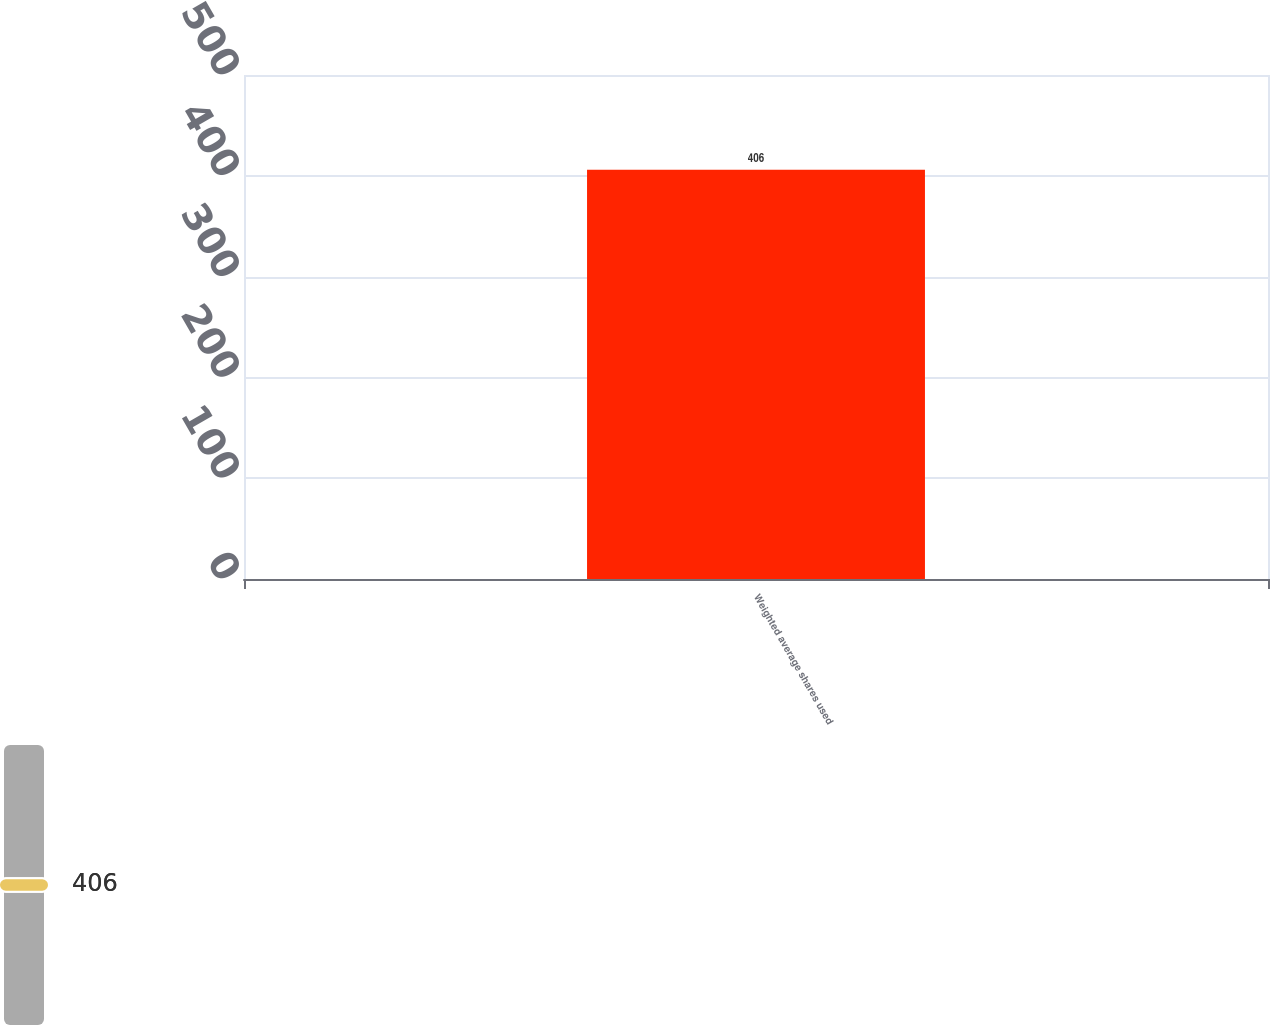Convert chart to OTSL. <chart><loc_0><loc_0><loc_500><loc_500><bar_chart><fcel>Weighted average shares used<nl><fcel>406<nl></chart> 